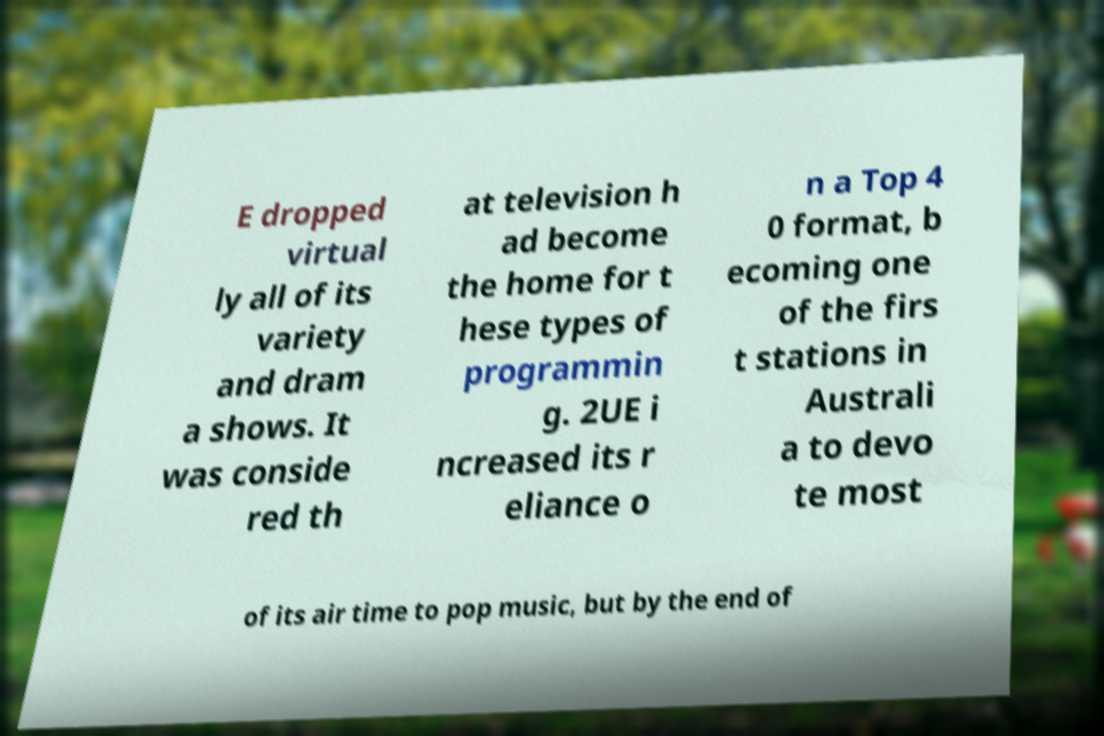I need the written content from this picture converted into text. Can you do that? E dropped virtual ly all of its variety and dram a shows. It was conside red th at television h ad become the home for t hese types of programmin g. 2UE i ncreased its r eliance o n a Top 4 0 format, b ecoming one of the firs t stations in Australi a to devo te most of its air time to pop music, but by the end of 